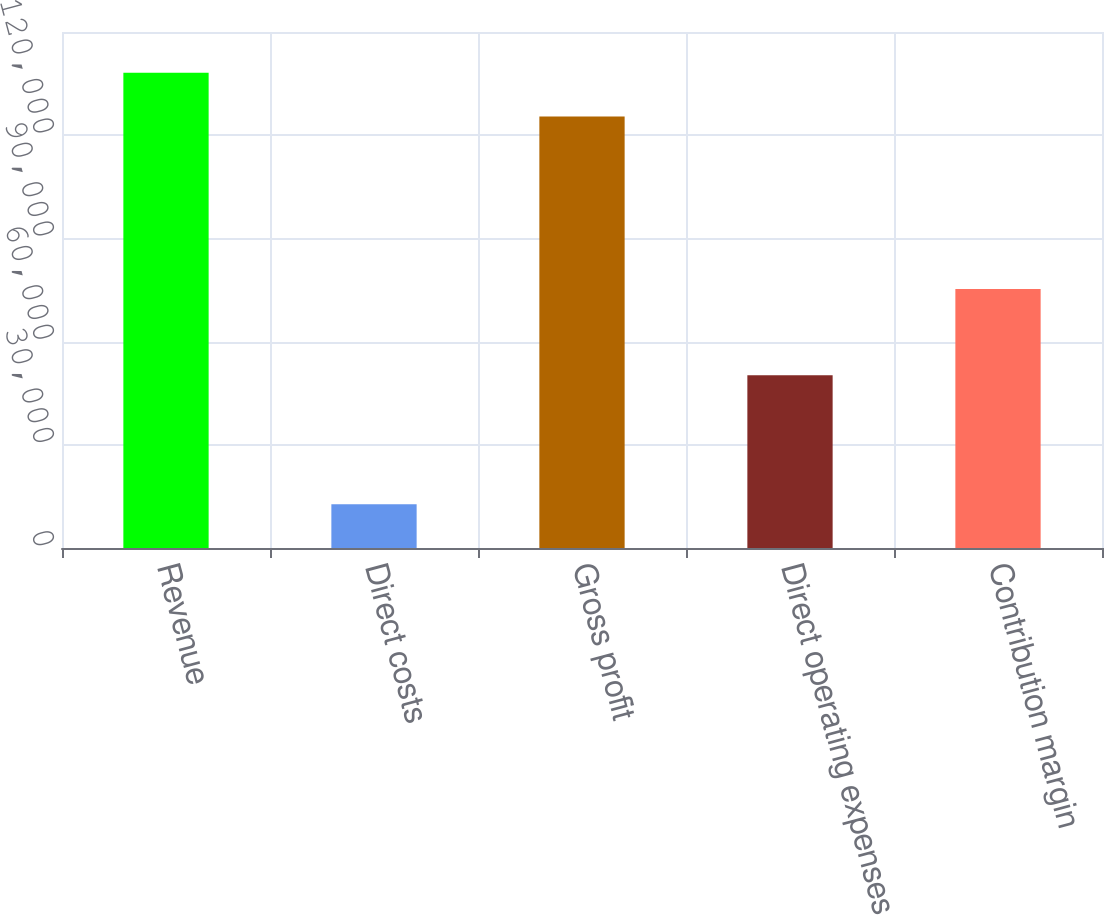Convert chart to OTSL. <chart><loc_0><loc_0><loc_500><loc_500><bar_chart><fcel>Revenue<fcel>Direct costs<fcel>Gross profit<fcel>Direct operating expenses<fcel>Contribution margin<nl><fcel>138165<fcel>12710<fcel>125455<fcel>50198<fcel>75257<nl></chart> 